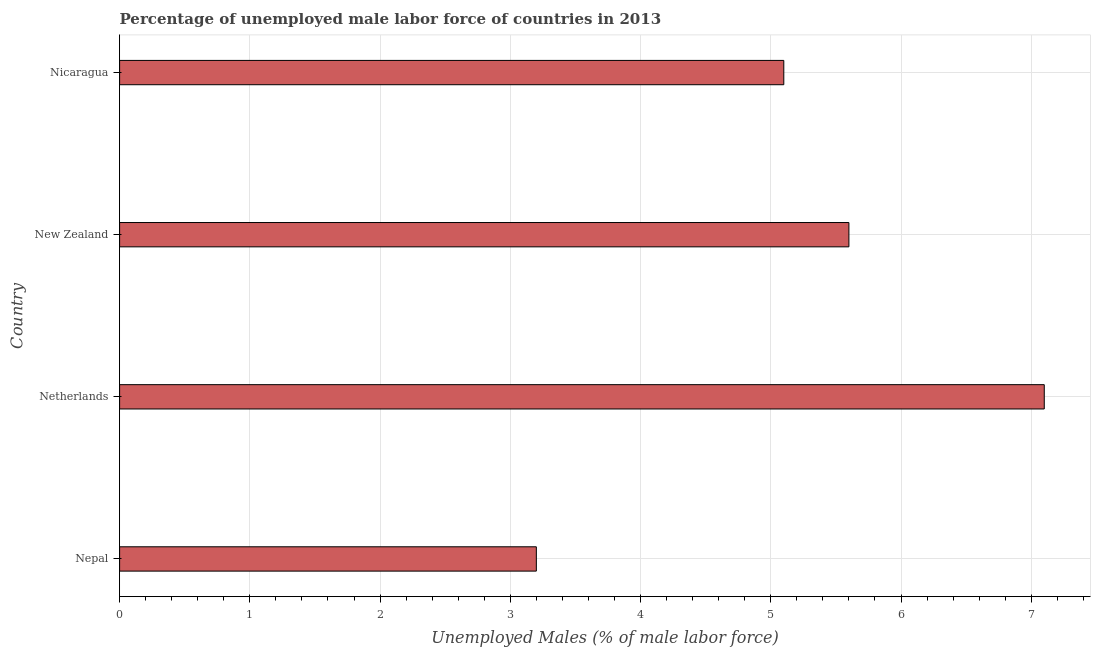Does the graph contain any zero values?
Make the answer very short. No. What is the title of the graph?
Make the answer very short. Percentage of unemployed male labor force of countries in 2013. What is the label or title of the X-axis?
Keep it short and to the point. Unemployed Males (% of male labor force). What is the label or title of the Y-axis?
Offer a terse response. Country. What is the total unemployed male labour force in Nepal?
Keep it short and to the point. 3.2. Across all countries, what is the maximum total unemployed male labour force?
Your response must be concise. 7.1. Across all countries, what is the minimum total unemployed male labour force?
Keep it short and to the point. 3.2. In which country was the total unemployed male labour force minimum?
Offer a very short reply. Nepal. What is the sum of the total unemployed male labour force?
Offer a terse response. 21. What is the average total unemployed male labour force per country?
Ensure brevity in your answer.  5.25. What is the median total unemployed male labour force?
Offer a very short reply. 5.35. In how many countries, is the total unemployed male labour force greater than 1 %?
Offer a very short reply. 4. What is the ratio of the total unemployed male labour force in Netherlands to that in New Zealand?
Ensure brevity in your answer.  1.27. How many bars are there?
Ensure brevity in your answer.  4. Are all the bars in the graph horizontal?
Provide a succinct answer. Yes. What is the difference between two consecutive major ticks on the X-axis?
Offer a very short reply. 1. What is the Unemployed Males (% of male labor force) in Nepal?
Provide a succinct answer. 3.2. What is the Unemployed Males (% of male labor force) in Netherlands?
Your answer should be very brief. 7.1. What is the Unemployed Males (% of male labor force) of New Zealand?
Offer a terse response. 5.6. What is the Unemployed Males (% of male labor force) in Nicaragua?
Provide a succinct answer. 5.1. What is the difference between the Unemployed Males (% of male labor force) in Nepal and Netherlands?
Your answer should be compact. -3.9. What is the difference between the Unemployed Males (% of male labor force) in Nepal and Nicaragua?
Keep it short and to the point. -1.9. What is the difference between the Unemployed Males (% of male labor force) in Netherlands and Nicaragua?
Keep it short and to the point. 2. What is the difference between the Unemployed Males (% of male labor force) in New Zealand and Nicaragua?
Keep it short and to the point. 0.5. What is the ratio of the Unemployed Males (% of male labor force) in Nepal to that in Netherlands?
Keep it short and to the point. 0.45. What is the ratio of the Unemployed Males (% of male labor force) in Nepal to that in New Zealand?
Ensure brevity in your answer.  0.57. What is the ratio of the Unemployed Males (% of male labor force) in Nepal to that in Nicaragua?
Ensure brevity in your answer.  0.63. What is the ratio of the Unemployed Males (% of male labor force) in Netherlands to that in New Zealand?
Your answer should be very brief. 1.27. What is the ratio of the Unemployed Males (% of male labor force) in Netherlands to that in Nicaragua?
Offer a terse response. 1.39. What is the ratio of the Unemployed Males (% of male labor force) in New Zealand to that in Nicaragua?
Your answer should be compact. 1.1. 